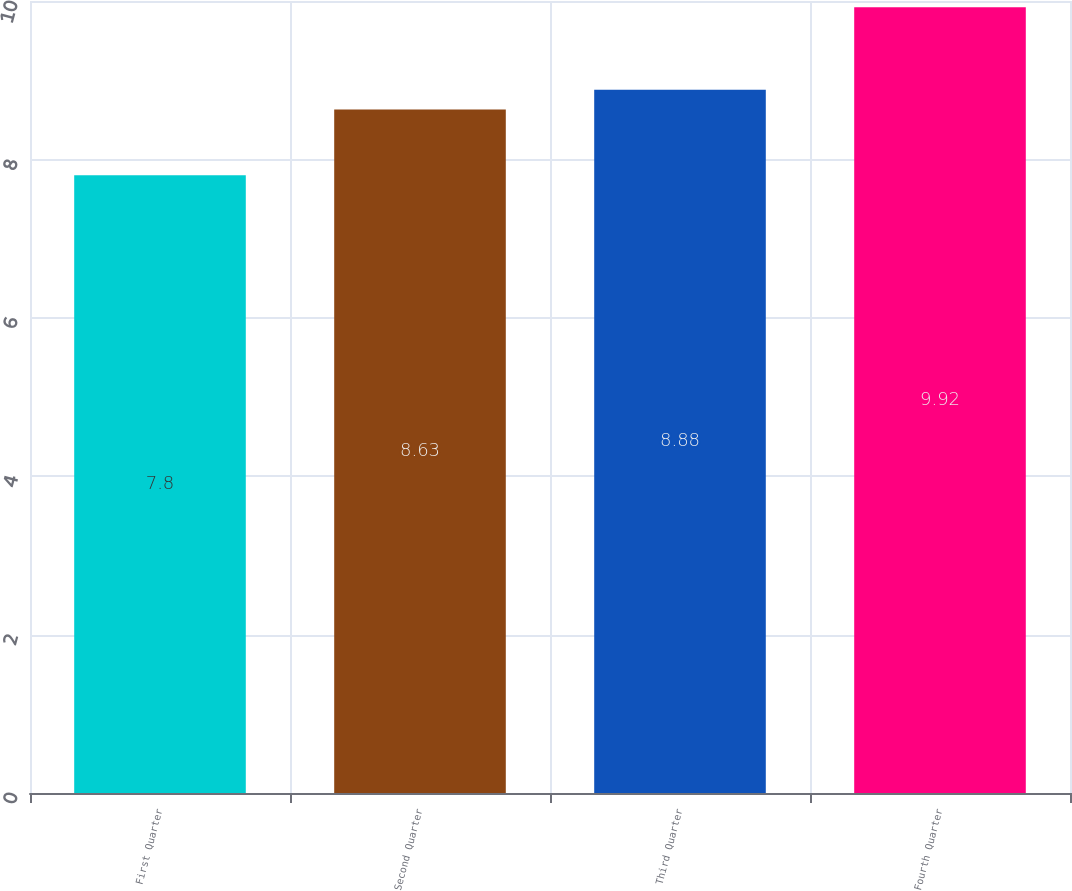<chart> <loc_0><loc_0><loc_500><loc_500><bar_chart><fcel>First Quarter<fcel>Second Quarter<fcel>Third Quarter<fcel>Fourth Quarter<nl><fcel>7.8<fcel>8.63<fcel>8.88<fcel>9.92<nl></chart> 